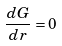Convert formula to latex. <formula><loc_0><loc_0><loc_500><loc_500>\frac { d G } { d r } = 0</formula> 